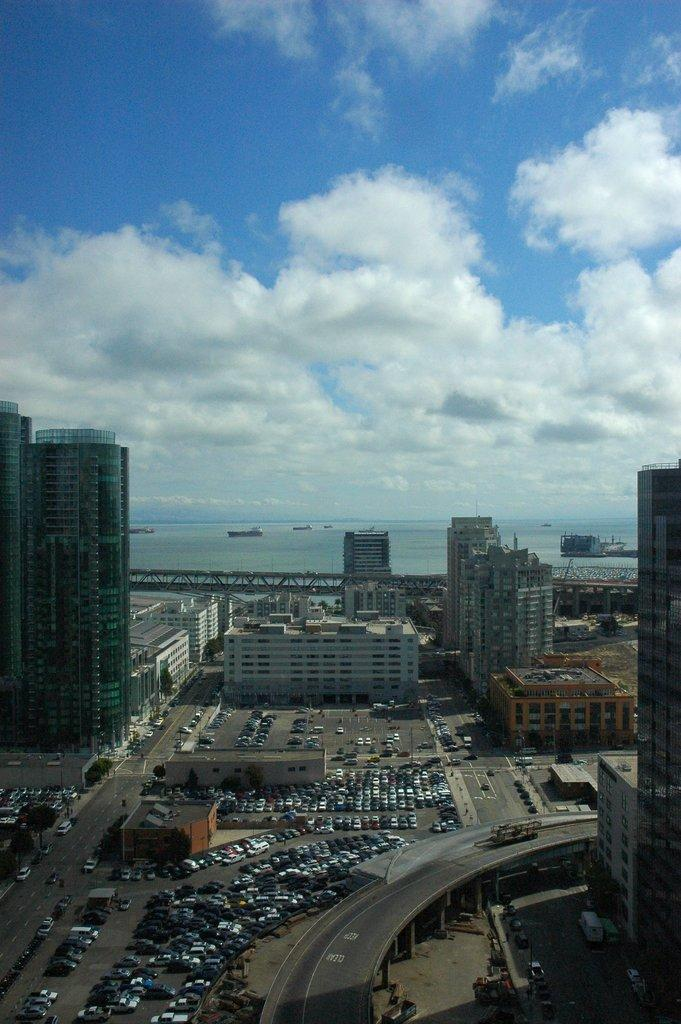What can be seen in the sky in the image? The sky is visible in the image, and there are clouds present. What type of structures can be seen in the image? There are buildings in the image. What mode of transportation is present in the image? Vehicles are present in the image. What natural element can be seen in the image? There is water visible in the image. What architectural feature is present in the image? Pillars are in the image. What type of man-made structure is featured in the image? The image features a bridge. How much profit can be made from the chairs in the image? There are no chairs present in the image, so it is not possible to determine any potential profit. 